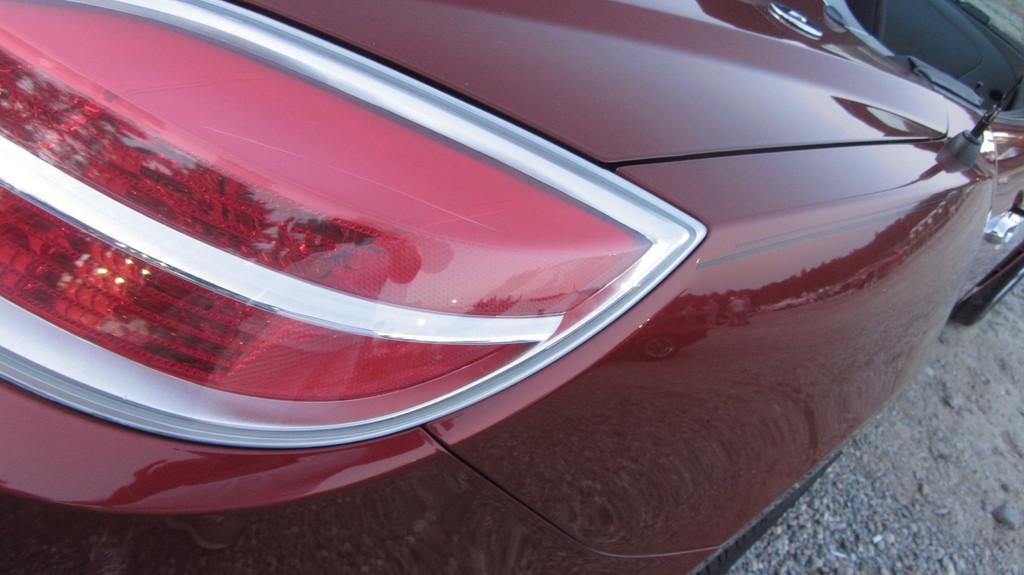Please provide a concise description of this image. In this image in the center there is one vehicle, and at the bottom there is a road. 